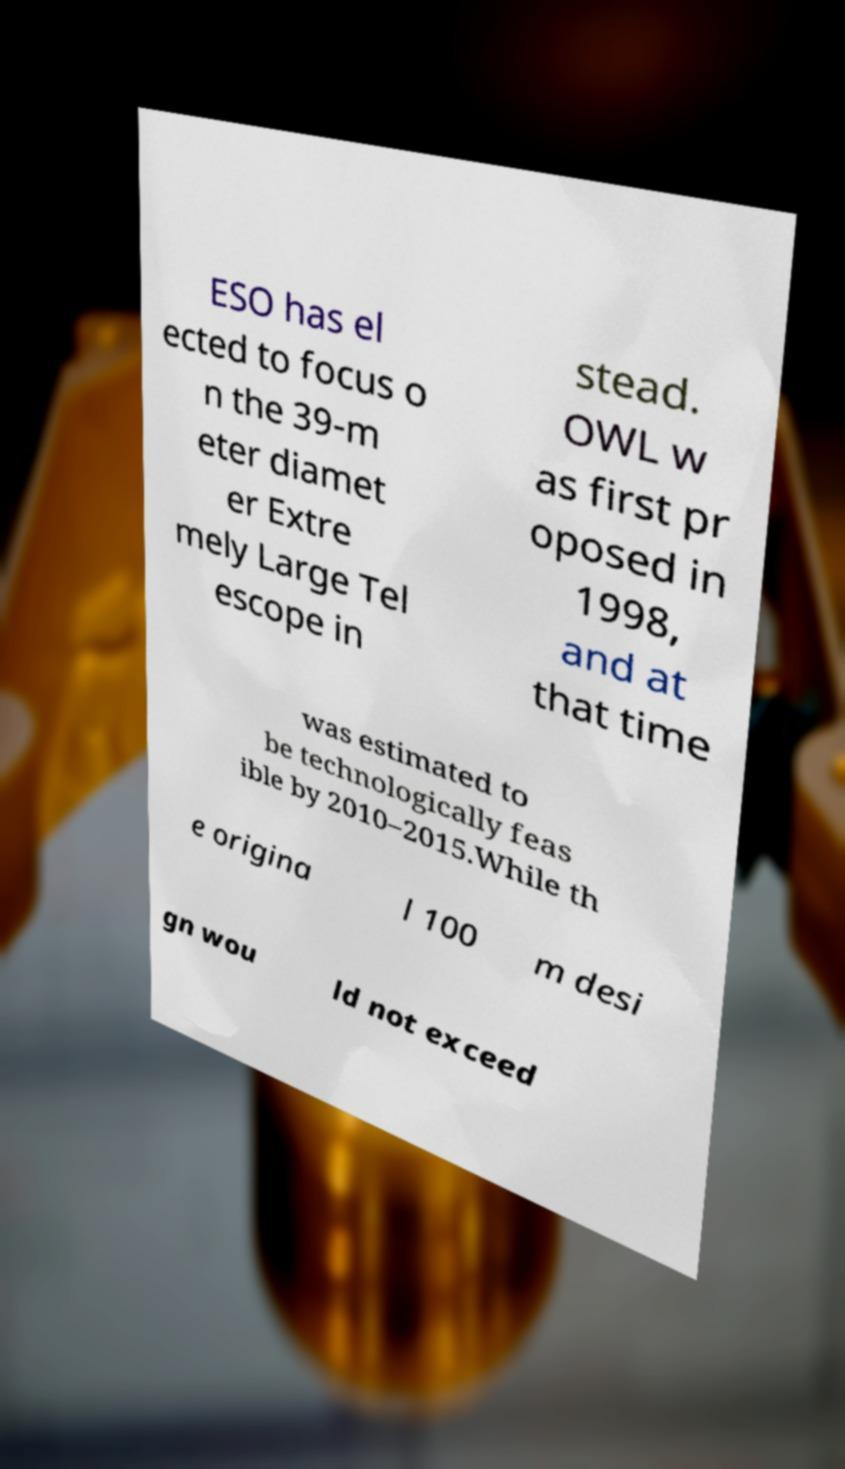Please read and relay the text visible in this image. What does it say? ESO has el ected to focus o n the 39-m eter diamet er Extre mely Large Tel escope in stead. OWL w as first pr oposed in 1998, and at that time was estimated to be technologically feas ible by 2010–2015.While th e origina l 100 m desi gn wou ld not exceed 